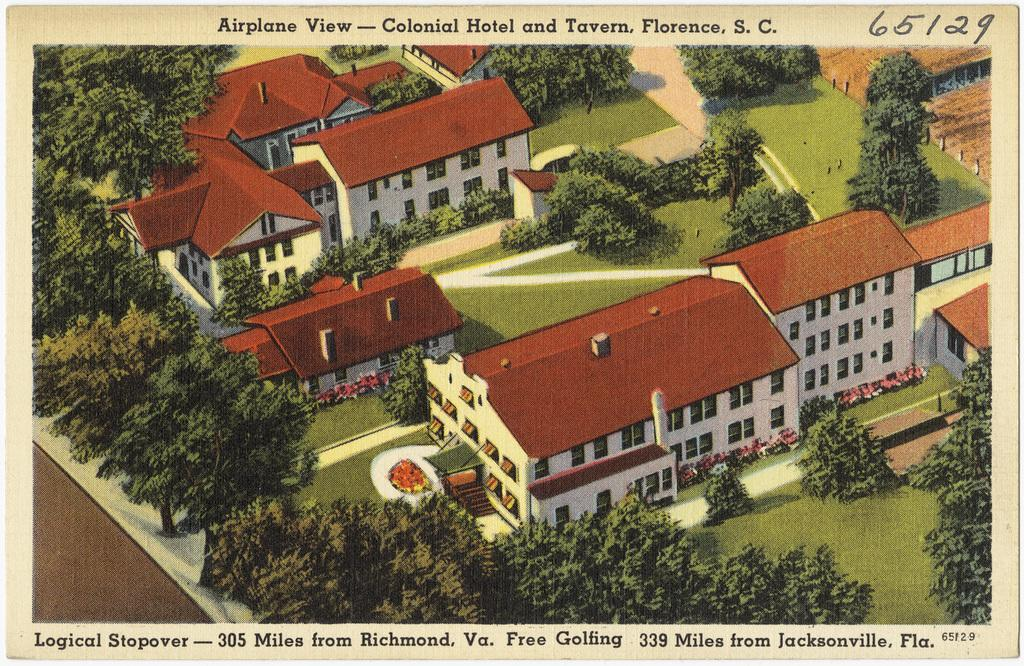What type of picture is in the image? The image contains an animated picture. What kind of structures can be seen in the image? There are buildings in the image. What type of vegetation is present in the image? There are plants, trees, and grass in the image. Is there any text or writing in the image? Yes, there is writing in the image at a few places. How many units are visible in the image? There are no units present in the image. 